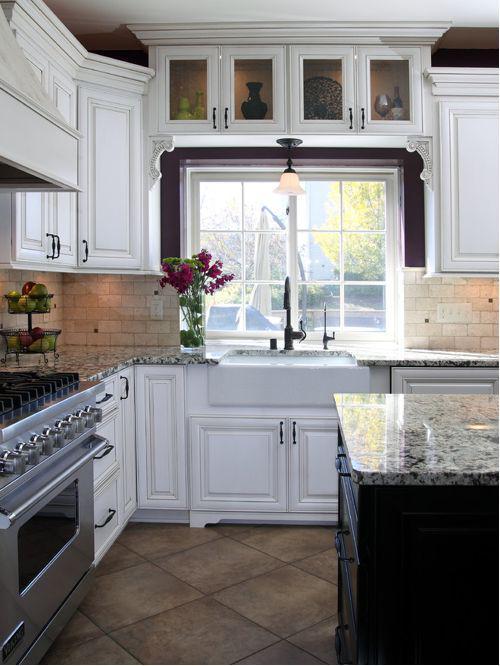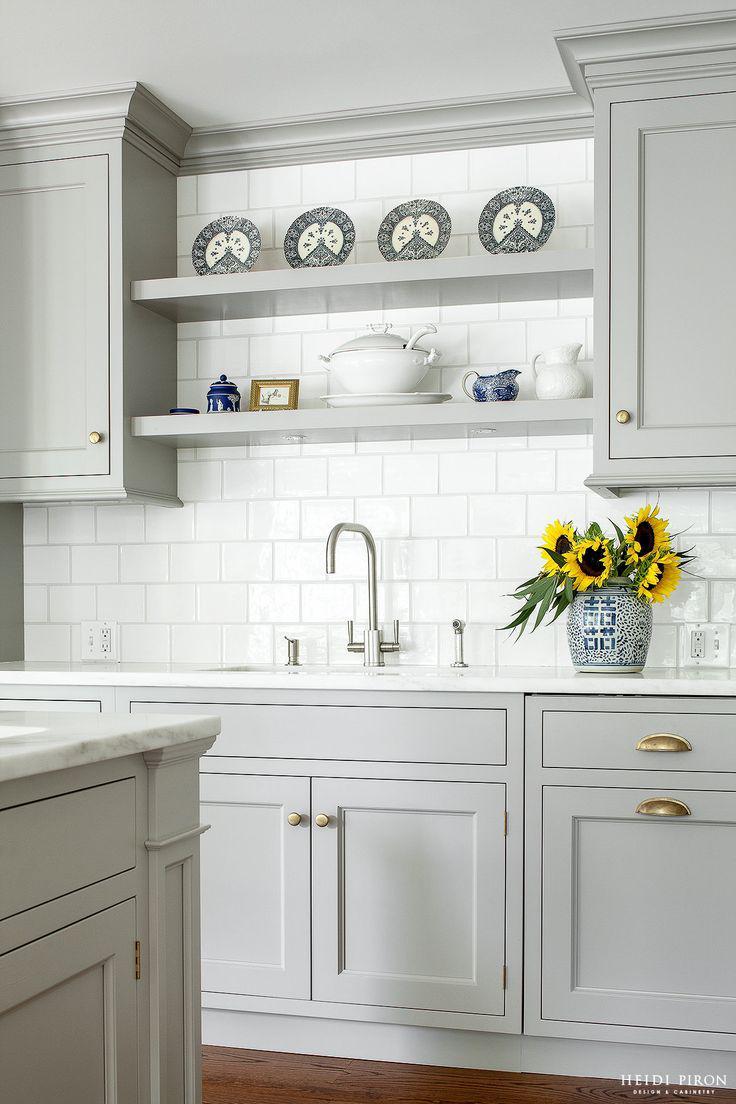The first image is the image on the left, the second image is the image on the right. For the images shown, is this caption "Both kitchens have outside windows." true? Answer yes or no. No. The first image is the image on the left, the second image is the image on the right. Assess this claim about the two images: "A plant in a container is to the left of the kitchen sink.". Correct or not? Answer yes or no. Yes. 